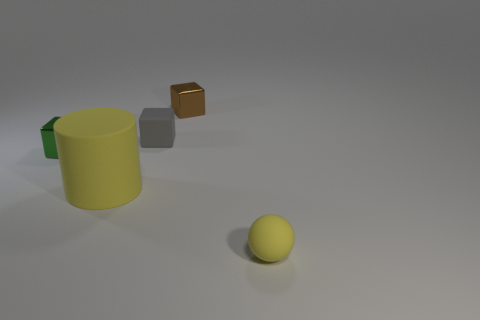What is the shape of the rubber thing that is the same color as the rubber sphere?
Keep it short and to the point. Cylinder. Do the object that is behind the small gray object and the tiny yellow thing have the same material?
Your answer should be compact. No. What number of other things are the same size as the brown metal block?
Offer a very short reply. 3. What number of tiny objects are either green rubber objects or green cubes?
Provide a short and direct response. 1. Is the tiny ball the same color as the rubber cylinder?
Keep it short and to the point. Yes. Are there more small things that are behind the tiny gray matte cube than green things behind the brown block?
Offer a very short reply. Yes. Do the small rubber thing that is in front of the yellow cylinder and the cylinder have the same color?
Your answer should be very brief. Yes. Are there any other things of the same color as the rubber sphere?
Your response must be concise. Yes. Are there more tiny gray blocks that are to the right of the green metallic thing than blue objects?
Keep it short and to the point. Yes. Do the brown metallic block and the yellow matte cylinder have the same size?
Offer a terse response. No. 